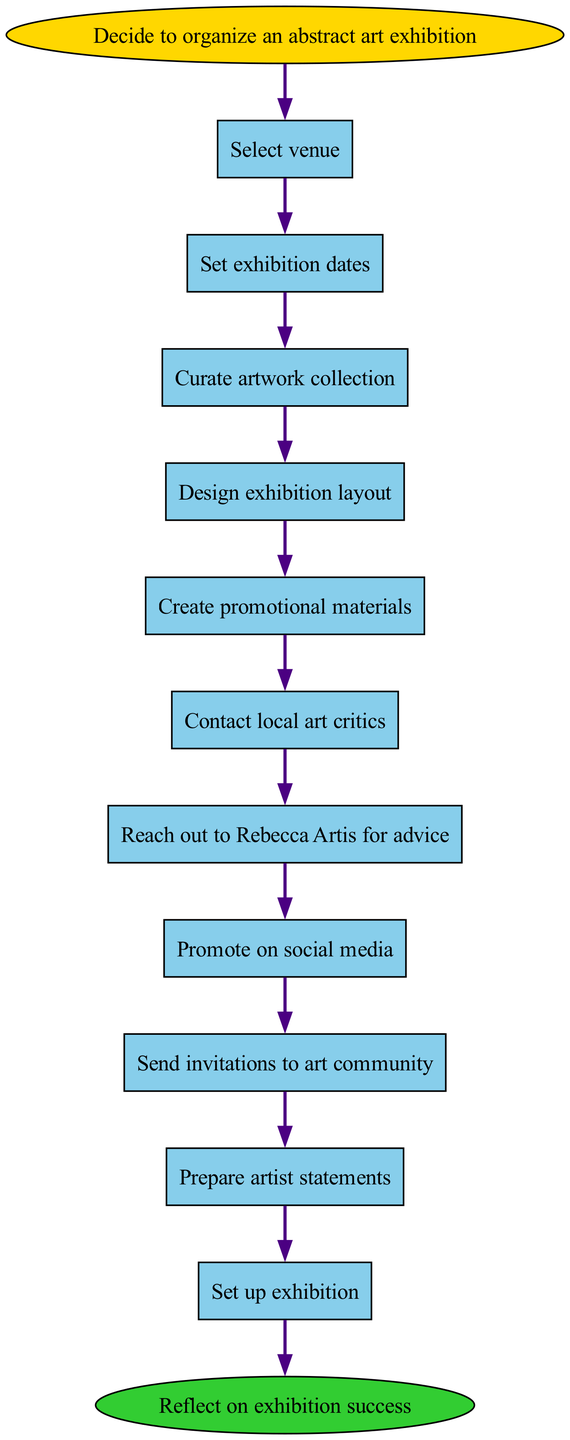What is the first step to organize the exhibition? The first step in the flow chart is marked as the starting node, which states "Decide to organize an abstract art exhibition." This can be directly seen at the top of the flow chart.
Answer: Decide to organize an abstract art exhibition How many steps are there in the diagram? By counting each node (step) listed in the diagram from "Select venue" to "Reflect on exhibition success," I find there are a total of 11 steps, including the start and end nodes.
Answer: 11 What is the last action before promoting on social media? To find this action, I need to follow the arrows from the node "Reach out to Rebecca Artis for advice." The next step after this node is "Promote on social media." This is the immediate next action and can be confirmed by tracing the flow direction.
Answer: Reach out to Rebecca Artis for advice Which node comes after "Set up exhibition"? The node that comes after "Set up exhibition" can be traced directly from the flow. After this action, the next step is "Host opening night." This is clearly shown by the connection between the two nodes.
Answer: Host opening night How many promotional activities are mentioned in the diagram? Looking closely at the steps labeled in the diagram, I can identify two promotional activities: "Create promotional materials" and "Promote on social media." By counting these activities, I confirm there are two.
Answer: 2 What is the purpose of contacting local art critics? The reason for contacting local art critics is to seek their feedback or coverage for the exhibition. It creates a pathway to "Reach out to Rebecca Artis for advice," which indicates that this action is part of a strategy to enhance exposure for the exhibition.
Answer: To enhance exposure Which step directly leads to preparing artist statements? The flow chart shows that after "Send invitations to art community," the next step is "Prepare artist statements." This means that preparing artist statements comes directly after sending those invitations.
Answer: Send invitations to art community If I want to start setting up the exhibition, which step should I have completed? To set up the exhibition, I must have completed all previous steps listed prior to "Set up exhibition." Specifically, the last completed step should have been "Prepare artist statements." This logical flow ensures readiness for the setup.
Answer: Prepare artist statements 